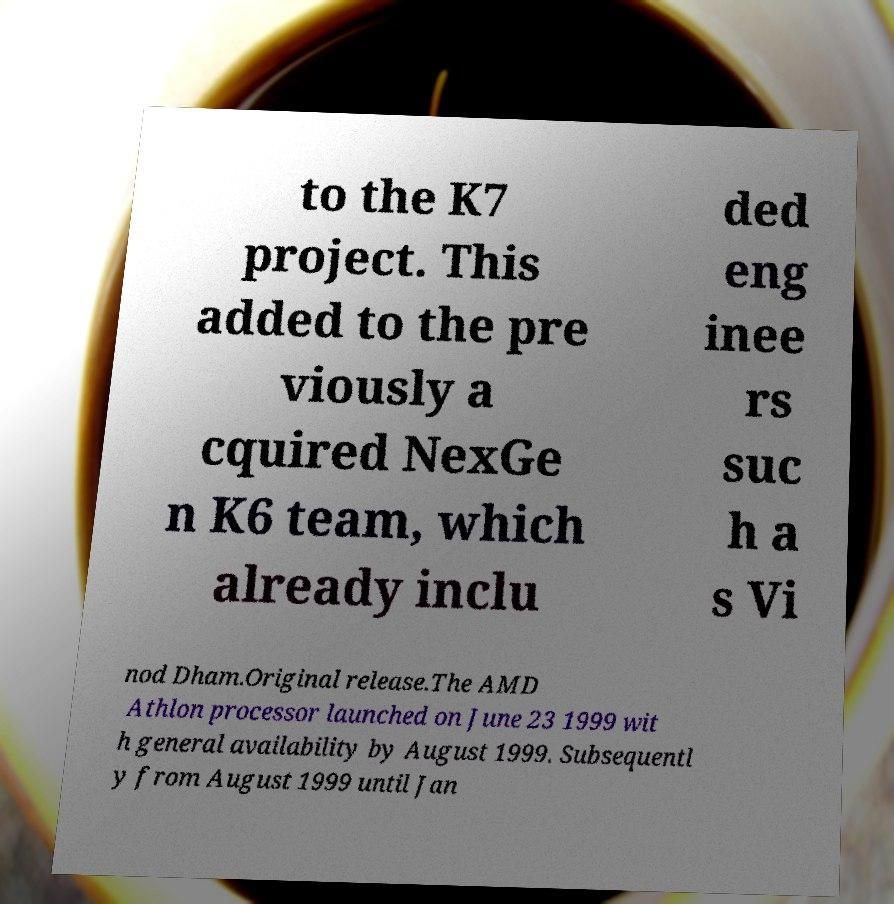Could you extract and type out the text from this image? to the K7 project. This added to the pre viously a cquired NexGe n K6 team, which already inclu ded eng inee rs suc h a s Vi nod Dham.Original release.The AMD Athlon processor launched on June 23 1999 wit h general availability by August 1999. Subsequentl y from August 1999 until Jan 